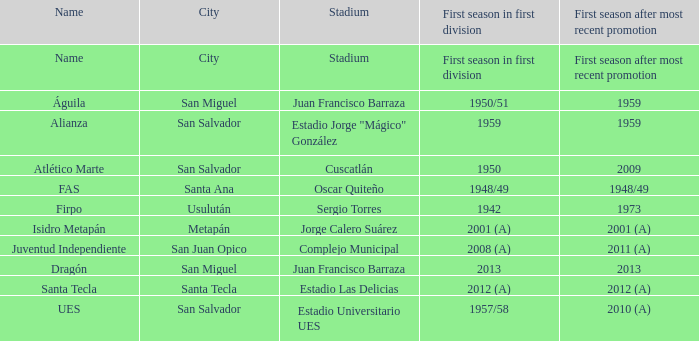When was Alianza's first season in first division with a promotion after 1959? 1959.0. 